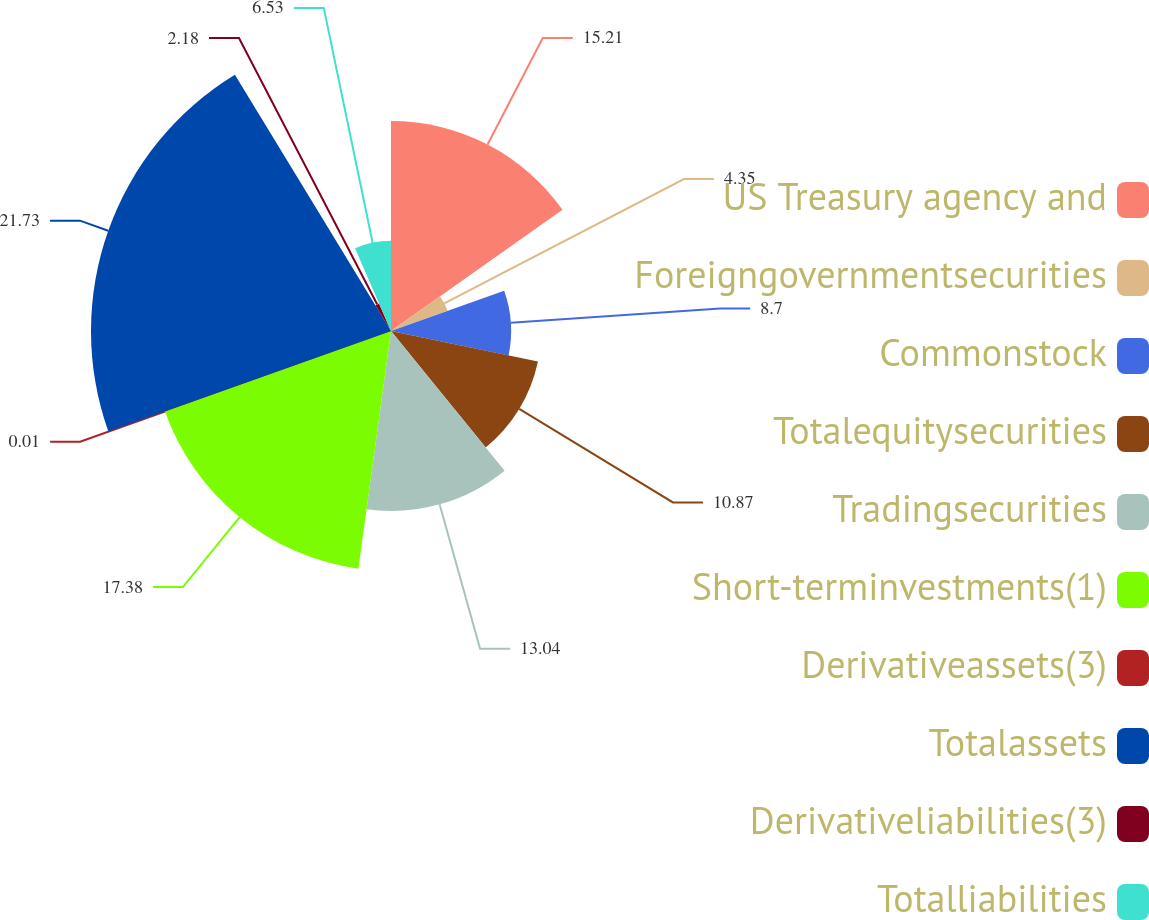Convert chart to OTSL. <chart><loc_0><loc_0><loc_500><loc_500><pie_chart><fcel>US Treasury agency and<fcel>Foreigngovernmentsecurities<fcel>Commonstock<fcel>Totalequitysecurities<fcel>Tradingsecurities<fcel>Short-terminvestments(1)<fcel>Derivativeassets(3)<fcel>Totalassets<fcel>Derivativeliabilities(3)<fcel>Totalliabilities<nl><fcel>15.21%<fcel>4.35%<fcel>8.7%<fcel>10.87%<fcel>13.04%<fcel>17.38%<fcel>0.01%<fcel>21.73%<fcel>2.18%<fcel>6.53%<nl></chart> 